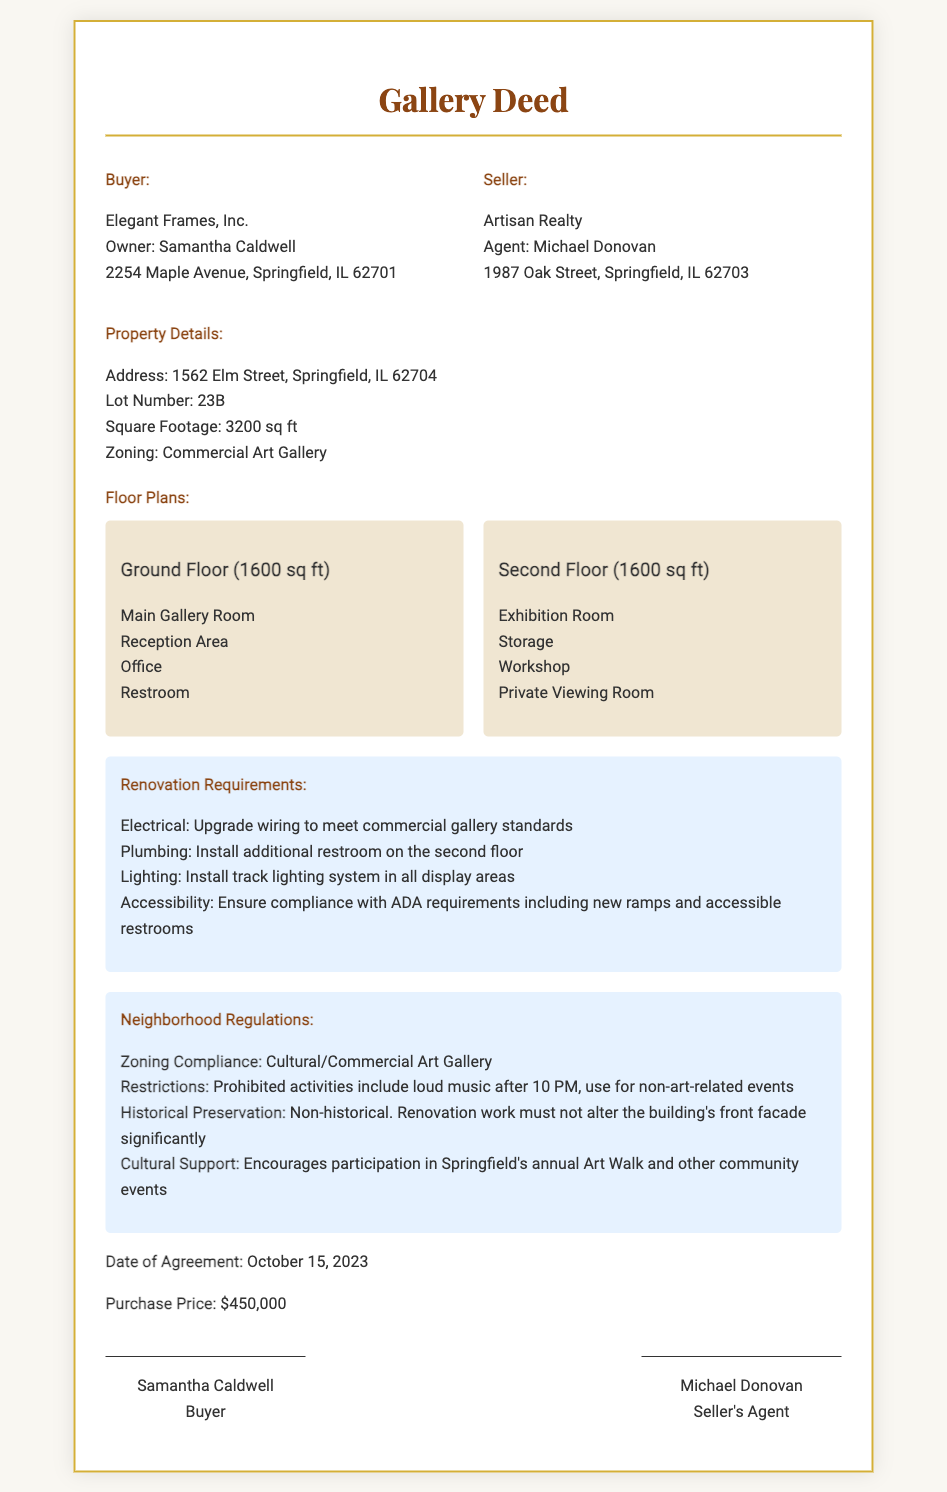What is the name of the buyer? The deed specifies the buyer as Elegant Frames, Inc.
Answer: Elegant Frames, Inc Who is the seller's agent? The document lists the seller's agent as Michael Donovan.
Answer: Michael Donovan What is the purchase price of the gallery space? The deed states that the purchase price is $450,000.
Answer: $450,000 How many square feet is the gallery space? The document mentions that the square footage is 3200 sq ft.
Answer: 3200 sq ft What are the main rooms on the ground floor? The deed includes a list of main rooms on the ground floor, which are the Main Gallery Room, Reception Area, Office, and Restroom.
Answer: Main Gallery Room, Reception Area, Office, Restroom What is one of the renovations required for compliance? The document mentions that an upgrade to wiring is necessary to meet commercial gallery standards.
Answer: Upgrade wiring What significant restriction is noted in the neighborhood regulations? The deed states that loud music is prohibited after 10 PM.
Answer: Loud music after 10 PM How many floors does the property have? The property has a ground floor and a second floor, totaling two floors.
Answer: Two floors What is the date of the agreement? The deed specifies that the date of the agreement is October 15, 2023.
Answer: October 15, 2023 